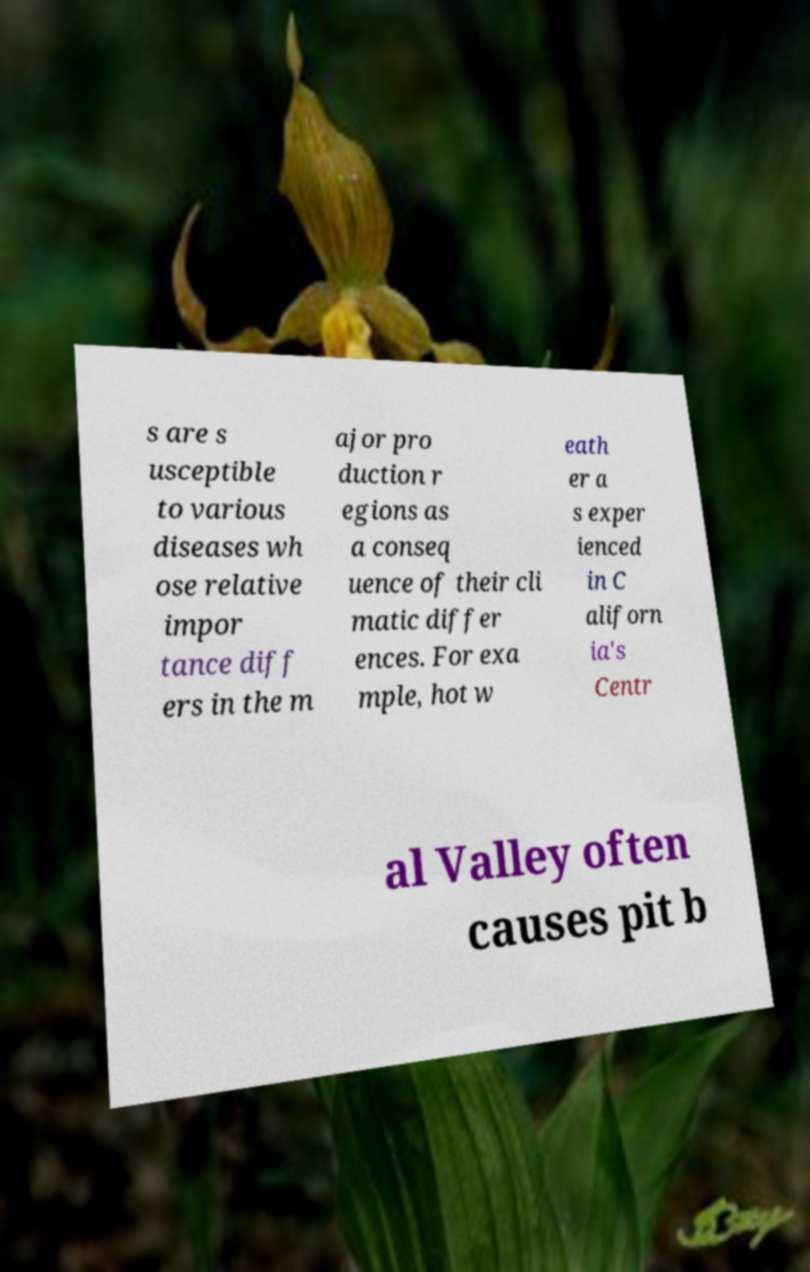Please identify and transcribe the text found in this image. s are s usceptible to various diseases wh ose relative impor tance diff ers in the m ajor pro duction r egions as a conseq uence of their cli matic differ ences. For exa mple, hot w eath er a s exper ienced in C aliforn ia's Centr al Valley often causes pit b 